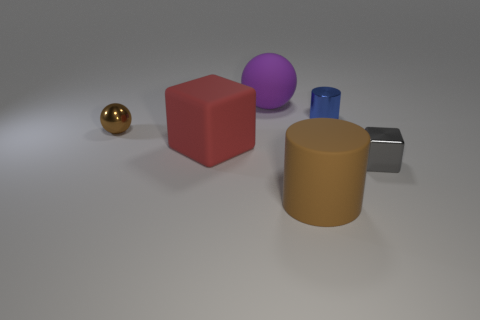What shape is the purple matte thing that is the same size as the matte block?
Provide a short and direct response. Sphere. Is there a large rubber object of the same color as the small metal sphere?
Ensure brevity in your answer.  Yes. Does the gray object have the same shape as the red thing?
Keep it short and to the point. Yes. What number of big objects are blue objects or gray things?
Give a very brief answer. 0. There is a big sphere that is made of the same material as the large brown cylinder; what color is it?
Provide a short and direct response. Purple. What number of big blue spheres are the same material as the small brown sphere?
Offer a very short reply. 0. There is a cylinder in front of the small gray block; does it have the same size as the shiny object that is in front of the small brown ball?
Provide a succinct answer. No. There is a cylinder in front of the block that is on the left side of the big brown object; what is it made of?
Give a very brief answer. Rubber. Are there fewer small brown metallic spheres that are in front of the tiny blue cylinder than things on the left side of the brown matte cylinder?
Provide a succinct answer. Yes. There is a thing that is the same color as the rubber cylinder; what is its material?
Keep it short and to the point. Metal. 